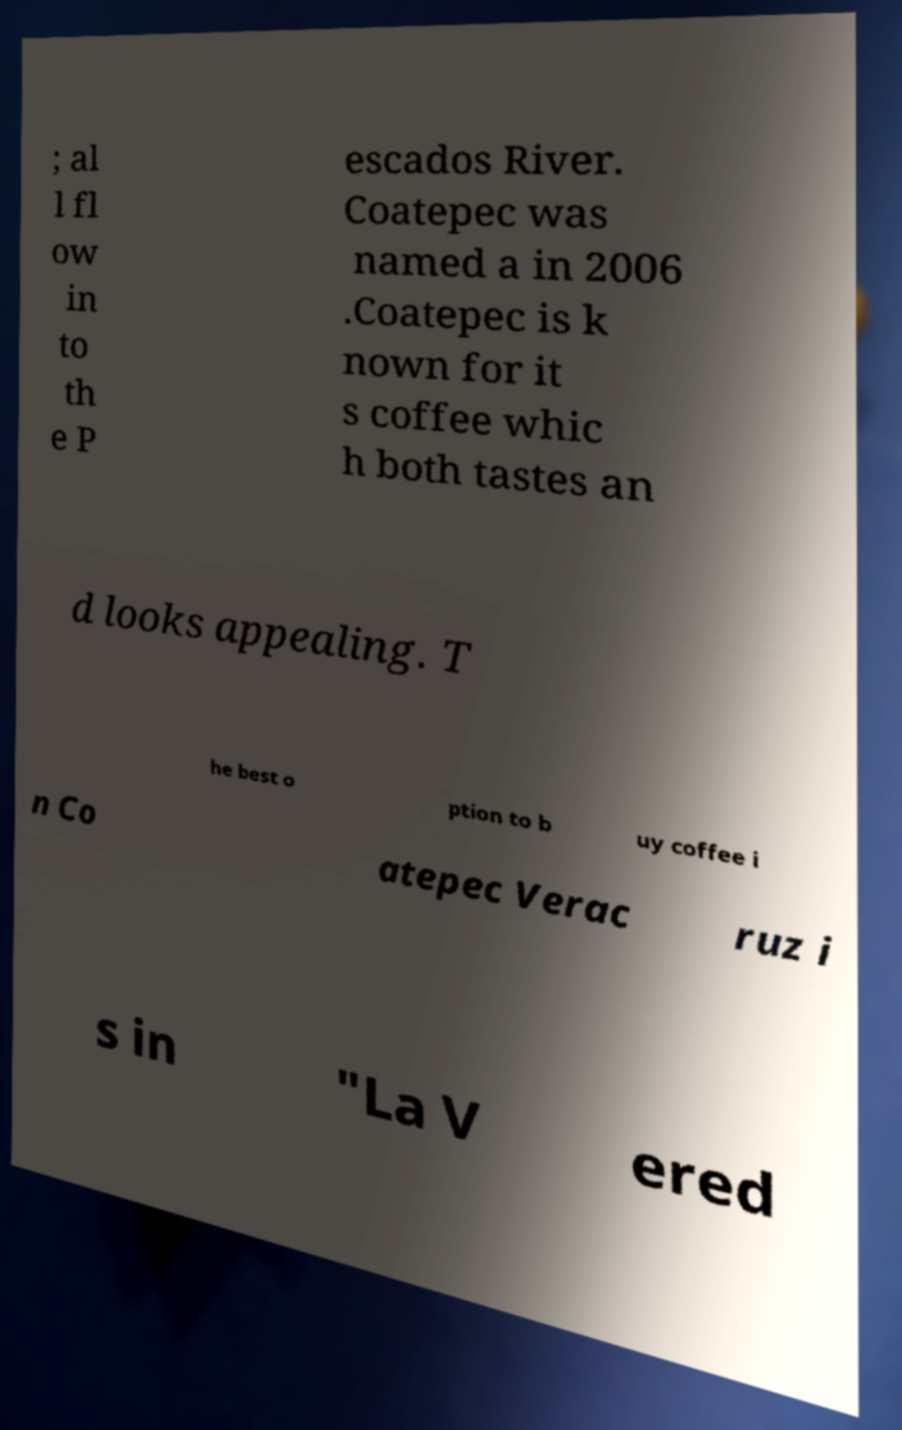I need the written content from this picture converted into text. Can you do that? ; al l fl ow in to th e P escados River. Coatepec was named a in 2006 .Coatepec is k nown for it s coffee whic h both tastes an d looks appealing. T he best o ption to b uy coffee i n Co atepec Verac ruz i s in "La V ered 